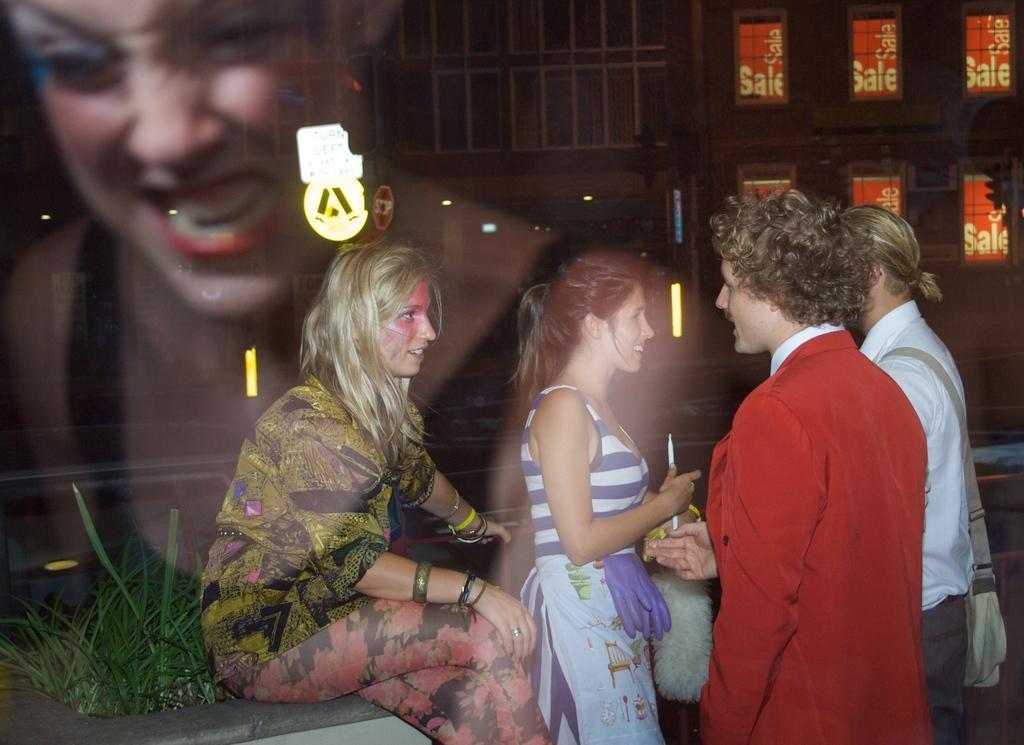Please provide a concise description of this image. This picture seems to be an edited image. On the right we can see the group of persons standing. On the left there is a person sitting on an object and we can see the green grass. In the background we can see the buildings and the windows of the buildings and we can see the text. On the left corner we can see the person and the lights. 